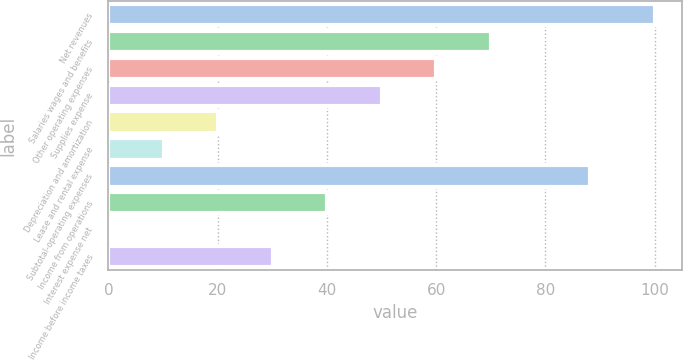Convert chart. <chart><loc_0><loc_0><loc_500><loc_500><bar_chart><fcel>Net revenues<fcel>Salaries wages and benefits<fcel>Other operating expenses<fcel>Supplies expense<fcel>Depreciation and amortization<fcel>Lease and rental expense<fcel>Subtotal-operating expenses<fcel>Income from operations<fcel>Interest expense net<fcel>Income before income taxes<nl><fcel>100<fcel>70.03<fcel>60.04<fcel>50.05<fcel>20.08<fcel>10.09<fcel>88.1<fcel>40.06<fcel>0.1<fcel>30.07<nl></chart> 